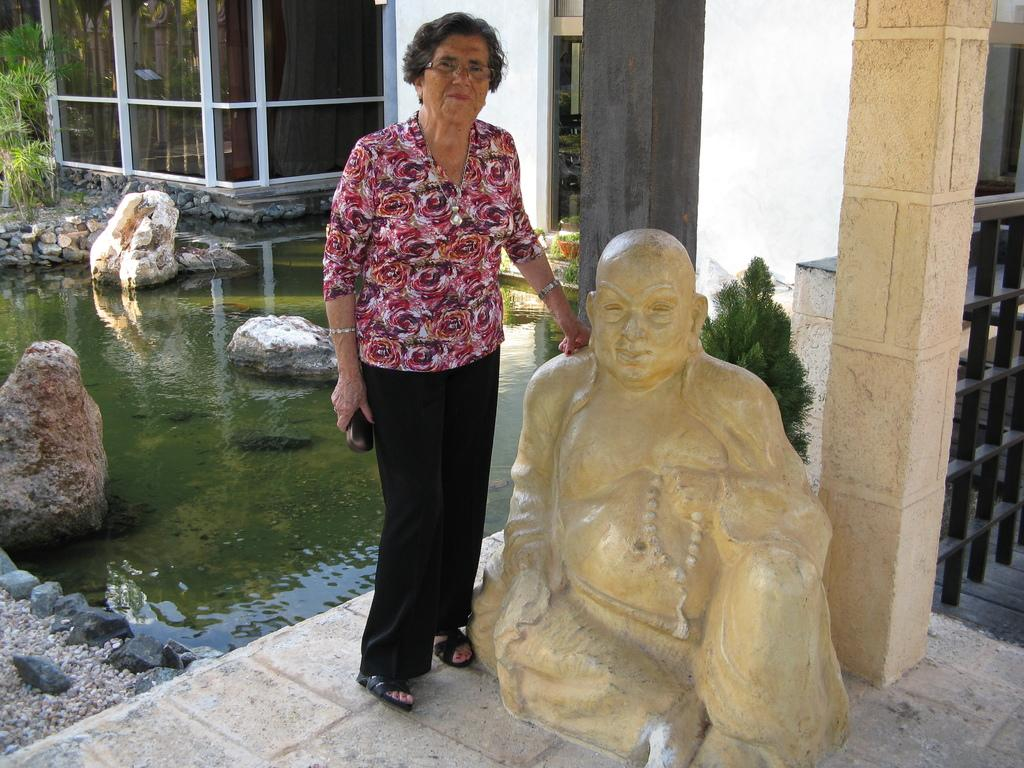What is the woman doing in the image? The woman is standing and smiling in the image. What natural feature can be seen in the image? There is a small pond in the image. What type of objects are present in the image? There are rocks, a sculpture, trees, a pillar, and a glass door in the image. Can you see the woman quivering in the image? No, the woman is standing and smiling, not quivering, in the image. 